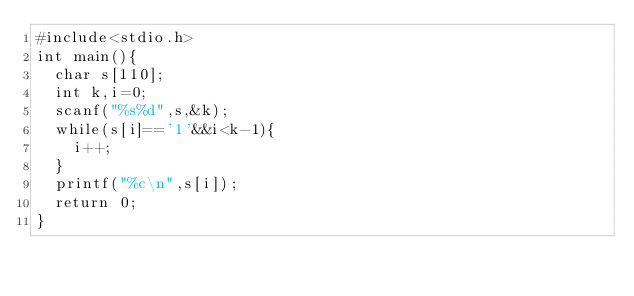<code> <loc_0><loc_0><loc_500><loc_500><_C_>#include<stdio.h>
int main(){
  char s[110];
  int k,i=0;
  scanf("%s%d",s,&k);
  while(s[i]=='1'&&i<k-1){
    i++;
  }
  printf("%c\n",s[i]);
  return 0;
}
</code> 